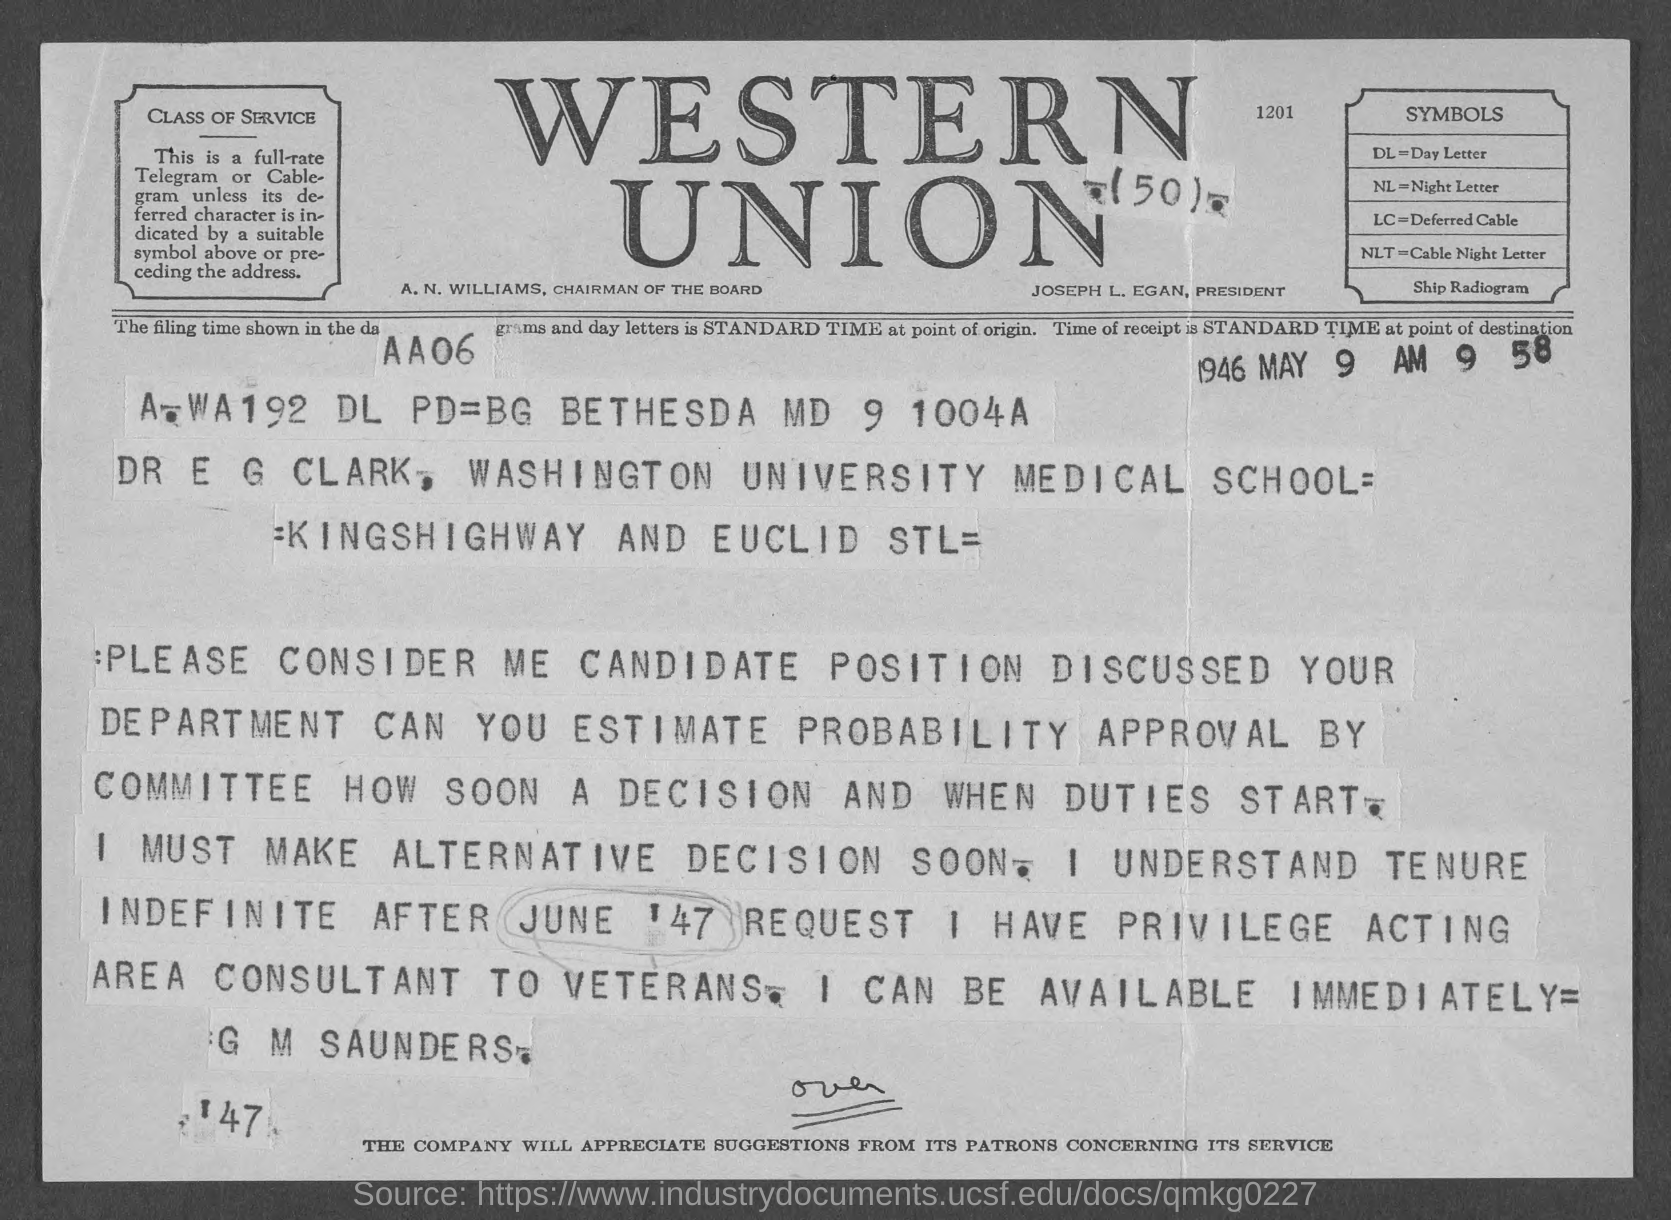Which firm is mentioned at the top of the page?
Provide a succinct answer. WESTERN UNION. What does the symbol DL stand for?
Your answer should be very brief. Day Letter. What does NLT denote?
Offer a terse response. Cable Night Letter. Who is the President?
Give a very brief answer. JOSEPH L. EGAN. What is A. N. WILLIAMS' title?
Ensure brevity in your answer.  CHAIRMAN OF THE BOARD. 